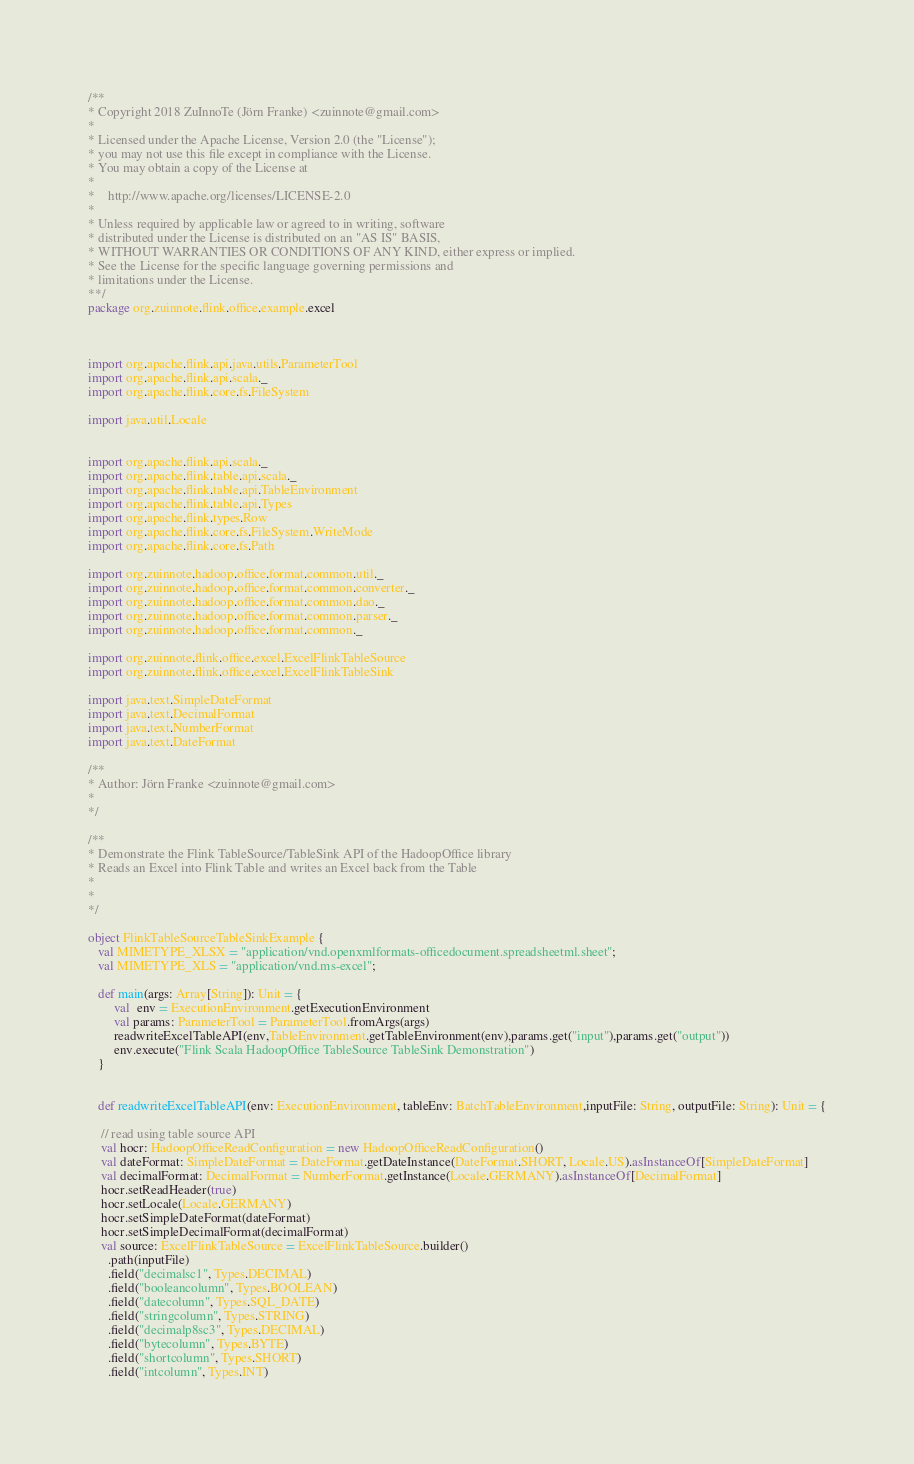<code> <loc_0><loc_0><loc_500><loc_500><_Scala_>/**
* Copyright 2018 ZuInnoTe (Jörn Franke) <zuinnote@gmail.com>
*
* Licensed under the Apache License, Version 2.0 (the "License");
* you may not use this file except in compliance with the License.
* You may obtain a copy of the License at
*
*    http://www.apache.org/licenses/LICENSE-2.0
*
* Unless required by applicable law or agreed to in writing, software
* distributed under the License is distributed on an "AS IS" BASIS,
* WITHOUT WARRANTIES OR CONDITIONS OF ANY KIND, either express or implied.
* See the License for the specific language governing permissions and
* limitations under the License.
**/
package org.zuinnote.flink.office.example.excel



import org.apache.flink.api.java.utils.ParameterTool
import org.apache.flink.api.scala._
import org.apache.flink.core.fs.FileSystem

import java.util.Locale


import org.apache.flink.api.scala._
import org.apache.flink.table.api.scala._
import org.apache.flink.table.api.TableEnvironment
import org.apache.flink.table.api.Types
import org.apache.flink.types.Row
import org.apache.flink.core.fs.FileSystem.WriteMode
import org.apache.flink.core.fs.Path

import org.zuinnote.hadoop.office.format.common.util._
import org.zuinnote.hadoop.office.format.common.converter._
import org.zuinnote.hadoop.office.format.common.dao._
import org.zuinnote.hadoop.office.format.common.parser._
import org.zuinnote.hadoop.office.format.common._

import org.zuinnote.flink.office.excel.ExcelFlinkTableSource
import org.zuinnote.flink.office.excel.ExcelFlinkTableSink

import java.text.SimpleDateFormat
import java.text.DecimalFormat
import java.text.NumberFormat
import java.text.DateFormat
   
/**
* Author: Jörn Franke <zuinnote@gmail.com>
*
*/

/**
* Demonstrate the Flink TableSource/TableSink API of the HadoopOffice library
* Reads an Excel into Flink Table and writes an Excel back from the Table
*
*
*/

object FlinkTableSourceTableSinkExample {
   val MIMETYPE_XLSX = "application/vnd.openxmlformats-officedocument.spreadsheetml.sheet";
   val MIMETYPE_XLS = "application/vnd.ms-excel";
  
   def main(args: Array[String]): Unit = {
 		val  env = ExecutionEnvironment.getExecutionEnvironment
        val params: ParameterTool = ParameterTool.fromArgs(args)
        readwriteExcelTableAPI(env,TableEnvironment.getTableEnvironment(env),params.get("input"),params.get("output"))
		env.execute("Flink Scala HadoopOffice TableSource TableSink Demonstration")
   }
   
   
   def readwriteExcelTableAPI(env: ExecutionEnvironment, tableEnv: BatchTableEnvironment,inputFile: String, outputFile: String): Unit = {

    // read using table source API
    val hocr: HadoopOfficeReadConfiguration = new HadoopOfficeReadConfiguration()
    val dateFormat: SimpleDateFormat = DateFormat.getDateInstance(DateFormat.SHORT, Locale.US).asInstanceOf[SimpleDateFormat]
    val decimalFormat: DecimalFormat = NumberFormat.getInstance(Locale.GERMANY).asInstanceOf[DecimalFormat]
    hocr.setReadHeader(true)
    hocr.setLocale(Locale.GERMANY)
    hocr.setSimpleDateFormat(dateFormat)
    hocr.setSimpleDecimalFormat(decimalFormat)
    val source: ExcelFlinkTableSource = ExcelFlinkTableSource.builder()
      .path(inputFile)
      .field("decimalsc1", Types.DECIMAL)
      .field("booleancolumn", Types.BOOLEAN)
      .field("datecolumn", Types.SQL_DATE)
      .field("stringcolumn", Types.STRING)
      .field("decimalp8sc3", Types.DECIMAL)
      .field("bytecolumn", Types.BYTE)
      .field("shortcolumn", Types.SHORT)
      .field("intcolumn", Types.INT)</code> 